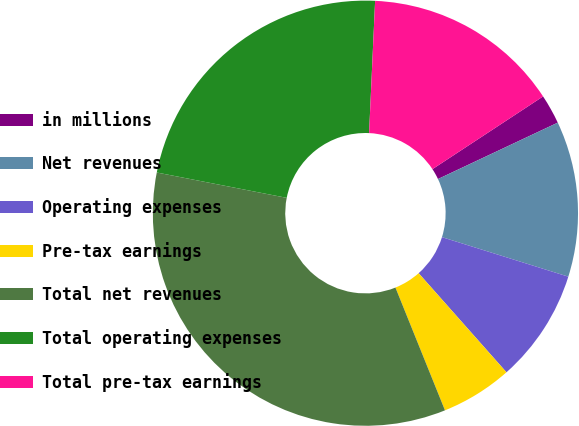<chart> <loc_0><loc_0><loc_500><loc_500><pie_chart><fcel>in millions<fcel>Net revenues<fcel>Operating expenses<fcel>Pre-tax earnings<fcel>Total net revenues<fcel>Total operating expenses<fcel>Total pre-tax earnings<nl><fcel>2.25%<fcel>11.83%<fcel>8.63%<fcel>5.44%<fcel>34.17%<fcel>22.66%<fcel>15.02%<nl></chart> 